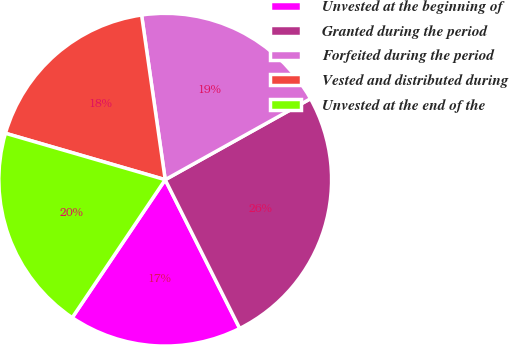Convert chart to OTSL. <chart><loc_0><loc_0><loc_500><loc_500><pie_chart><fcel>Unvested at the beginning of<fcel>Granted during the period<fcel>Forfeited during the period<fcel>Vested and distributed during<fcel>Unvested at the end of the<nl><fcel>16.83%<fcel>25.7%<fcel>19.17%<fcel>18.23%<fcel>20.06%<nl></chart> 